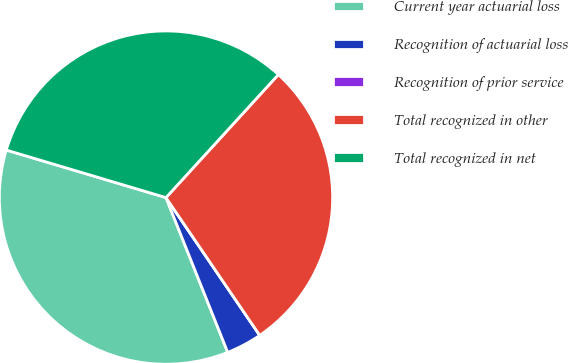Convert chart. <chart><loc_0><loc_0><loc_500><loc_500><pie_chart><fcel>Current year actuarial loss<fcel>Recognition of actuarial loss<fcel>Recognition of prior service<fcel>Total recognized in other<fcel>Total recognized in net<nl><fcel>35.65%<fcel>3.47%<fcel>0.0%<fcel>28.71%<fcel>32.18%<nl></chart> 